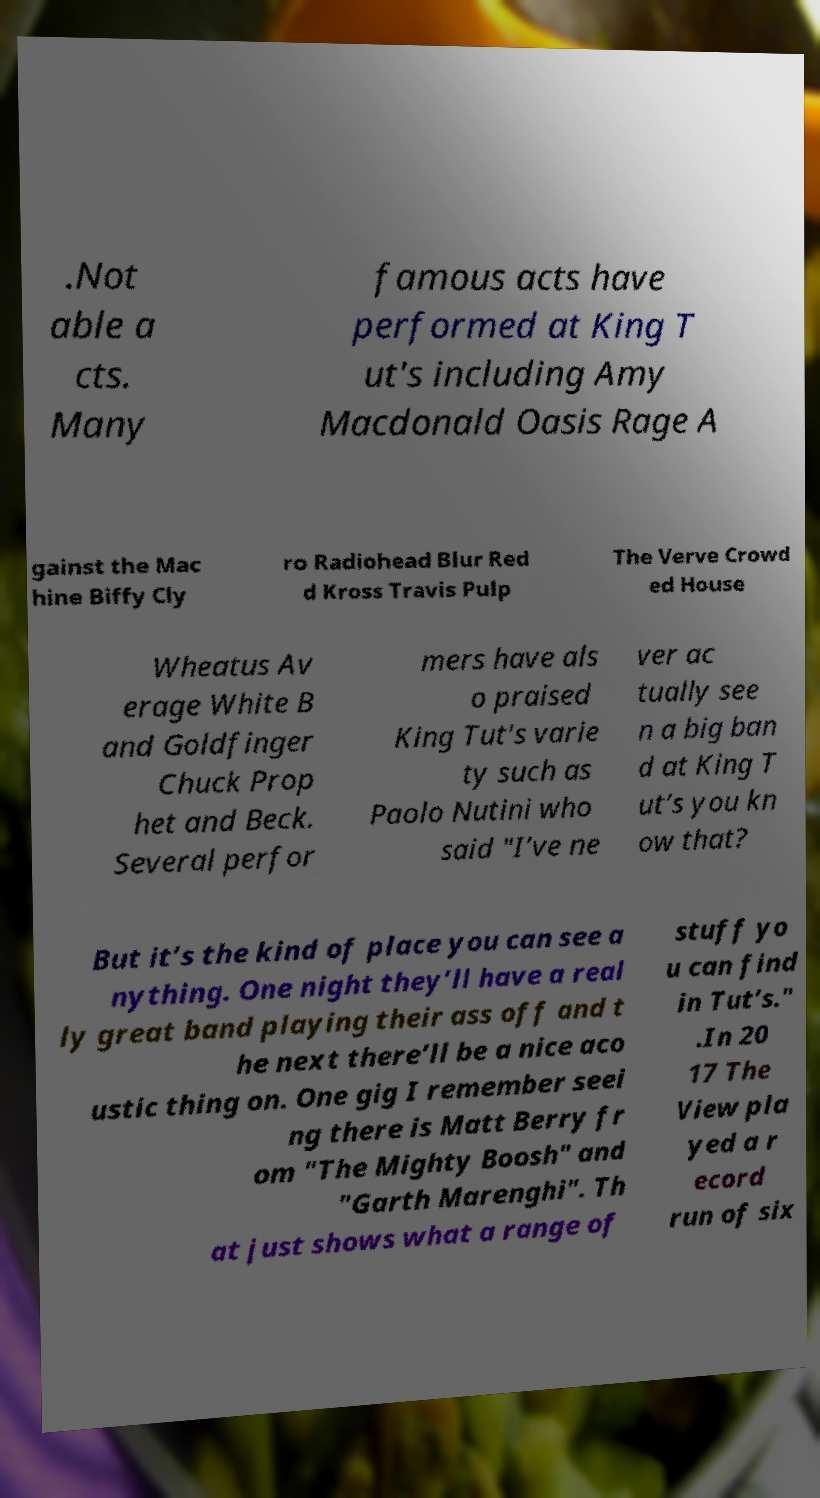I need the written content from this picture converted into text. Can you do that? .Not able a cts. Many famous acts have performed at King T ut's including Amy Macdonald Oasis Rage A gainst the Mac hine Biffy Cly ro Radiohead Blur Red d Kross Travis Pulp The Verve Crowd ed House Wheatus Av erage White B and Goldfinger Chuck Prop het and Beck. Several perfor mers have als o praised King Tut's varie ty such as Paolo Nutini who said "I’ve ne ver ac tually see n a big ban d at King T ut’s you kn ow that? But it’s the kind of place you can see a nything. One night they’ll have a real ly great band playing their ass off and t he next there’ll be a nice aco ustic thing on. One gig I remember seei ng there is Matt Berry fr om "The Mighty Boosh" and "Garth Marenghi". Th at just shows what a range of stuff yo u can find in Tut’s." .In 20 17 The View pla yed a r ecord run of six 